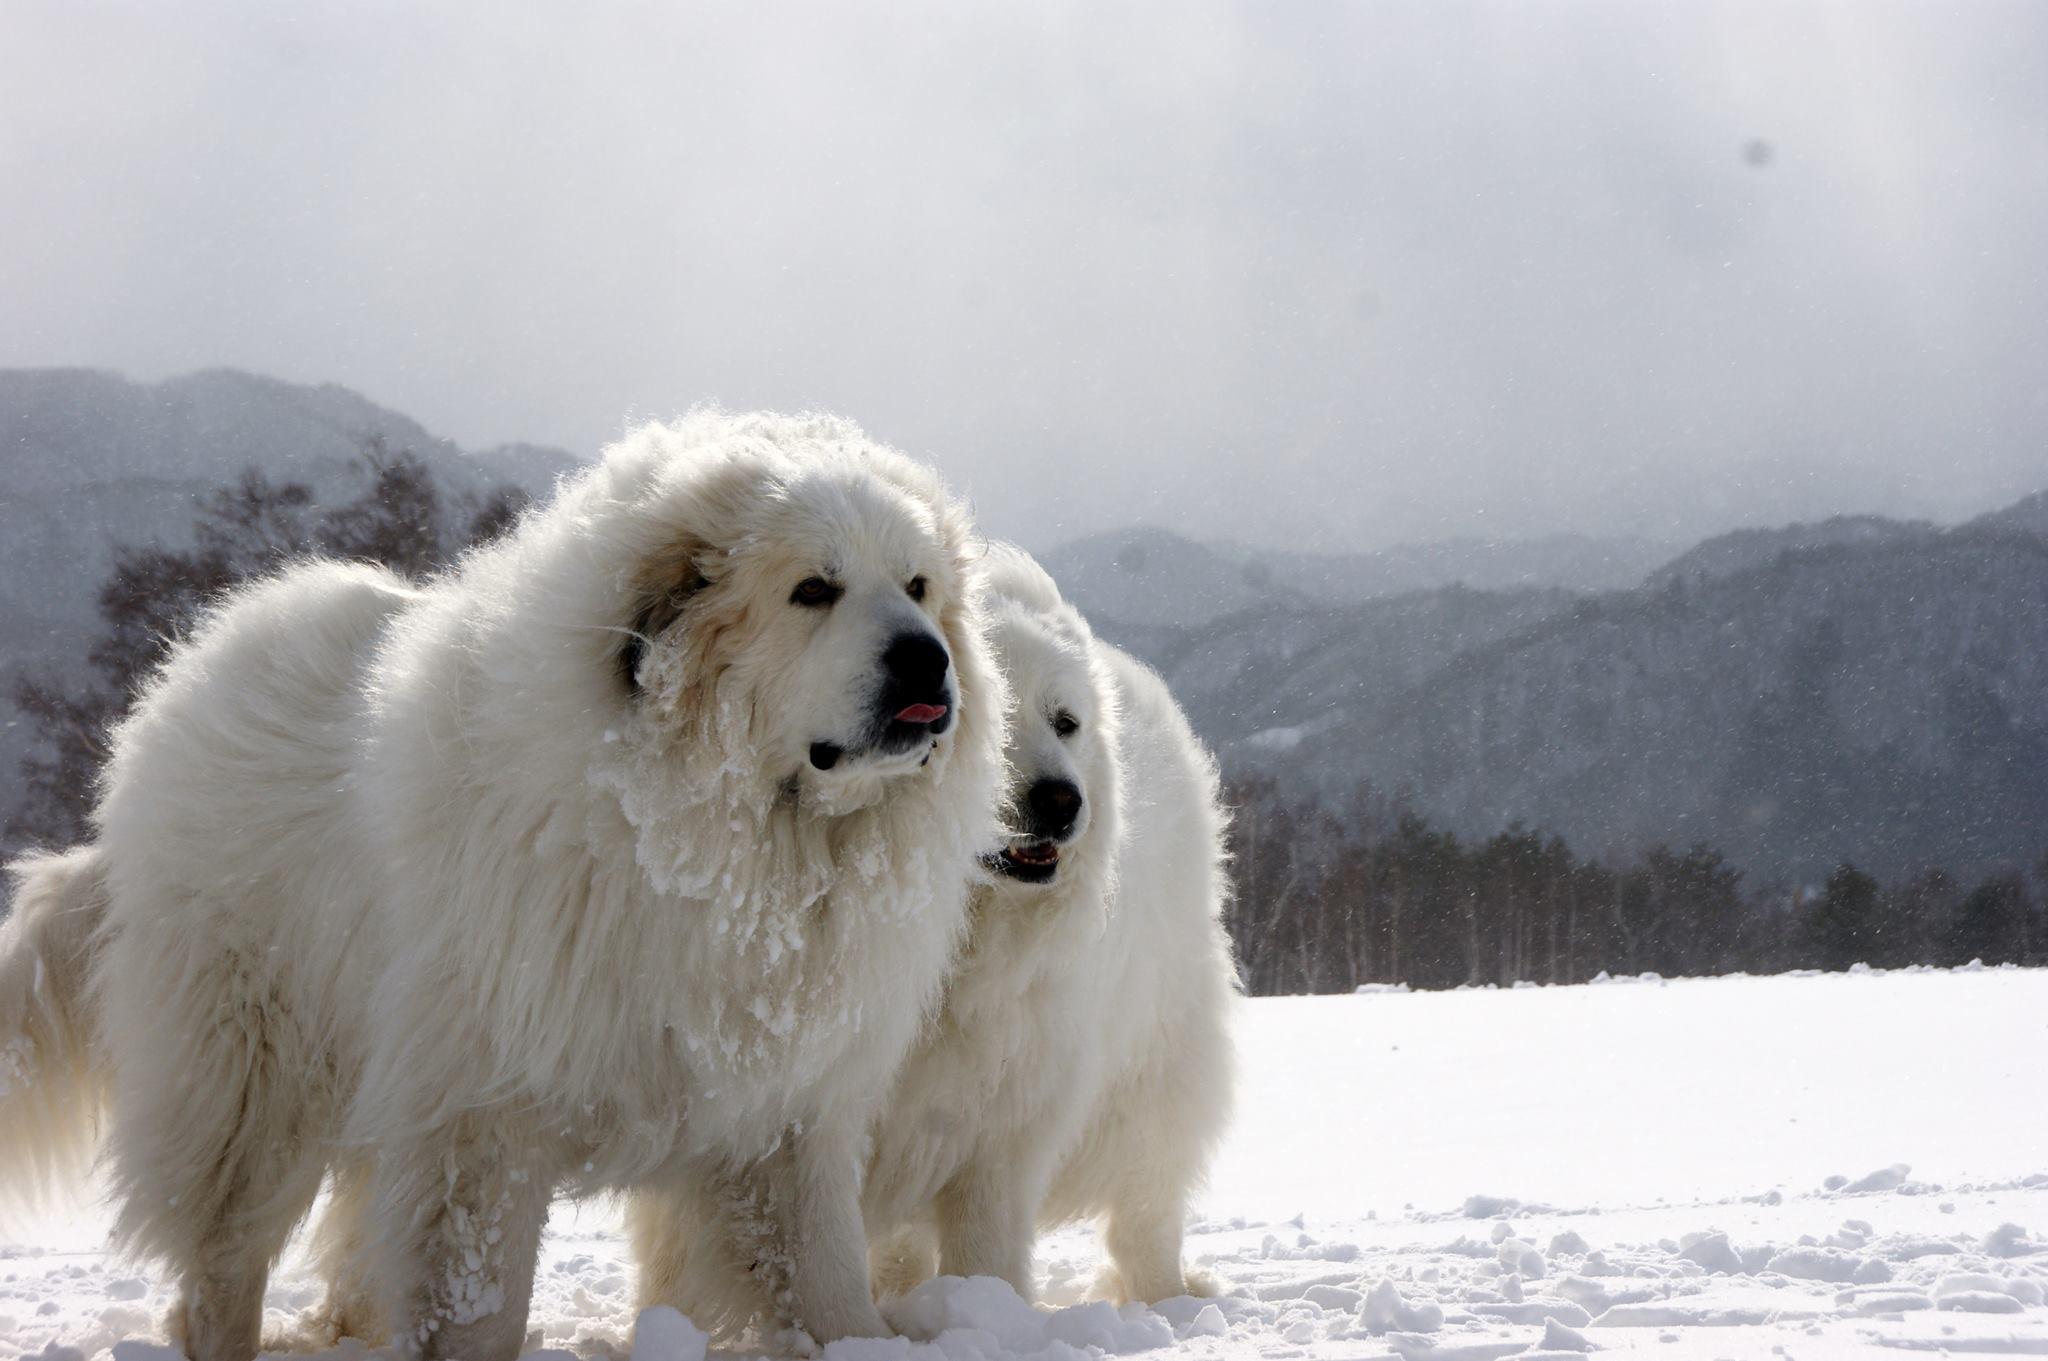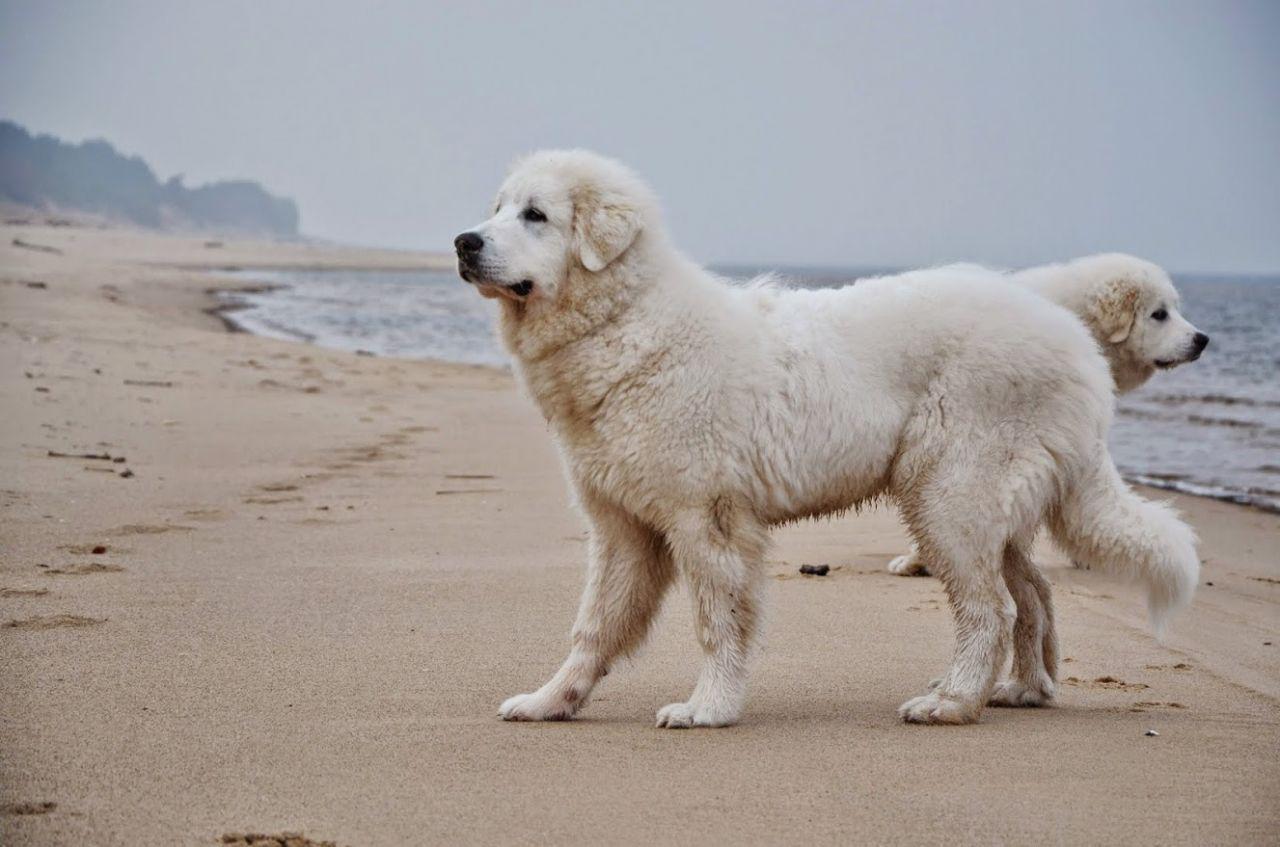The first image is the image on the left, the second image is the image on the right. Analyze the images presented: Is the assertion "Exactly three large white dogs are shown in outdoor settings." valid? Answer yes or no. No. The first image is the image on the left, the second image is the image on the right. Assess this claim about the two images: "There are a total of three dogs, and there are more dogs in the left image.". Correct or not? Answer yes or no. No. 